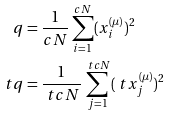<formula> <loc_0><loc_0><loc_500><loc_500>q & = \frac { 1 } { c N } \sum _ { i = 1 } ^ { c N } ( x _ { i } ^ { ( \mu ) } ) ^ { 2 } \\ \ t q & = \frac { 1 } { \ t c N } \sum _ { j = 1 } ^ { \ t c N } ( \ t x _ { j } ^ { ( \mu ) } ) ^ { 2 }</formula> 